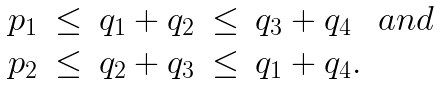Convert formula to latex. <formula><loc_0><loc_0><loc_500><loc_500>\begin{array} { l c l c l c } p _ { 1 } & \leq & q _ { 1 } + q _ { 2 } & \leq & q _ { 3 } + q _ { 4 } & a n d \\ p _ { 2 } & \leq & q _ { 2 } + q _ { 3 } & \leq & q _ { 1 } + q _ { 4 } . & \end{array}</formula> 